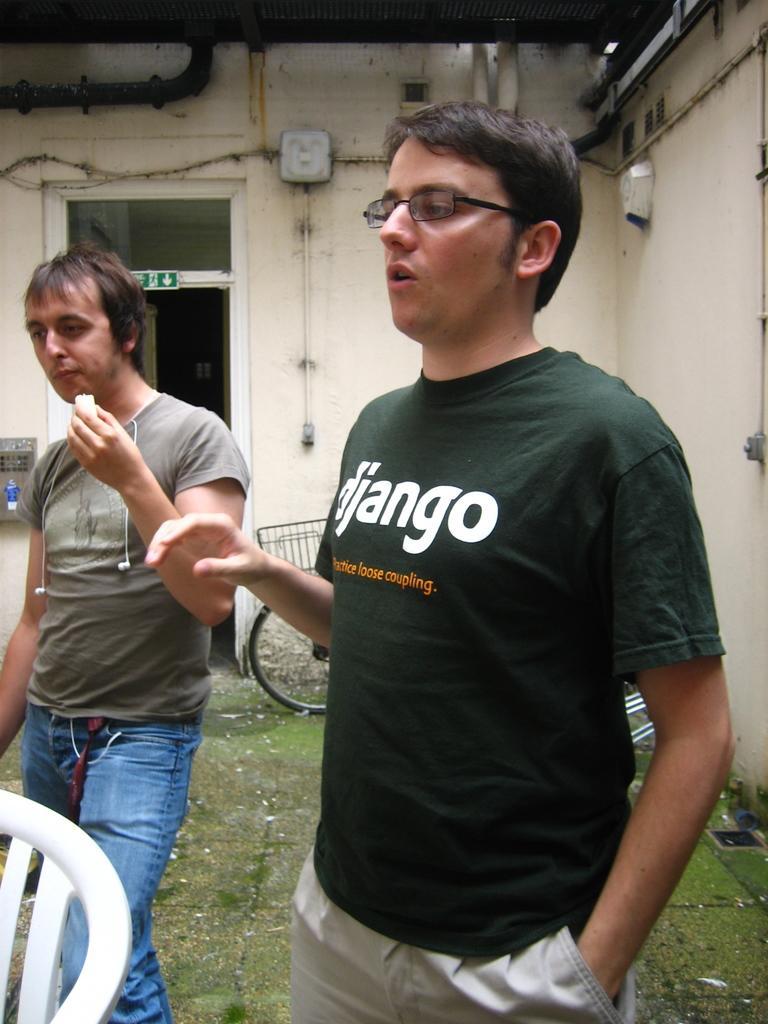Please provide a concise description of this image. In this image we can see two persons. We can also see the chair, bicycle on the surface. In the background we can see the entrance to access to the room. We can also see the walls and the tubes with electrical boxes. Roof is also visible. 